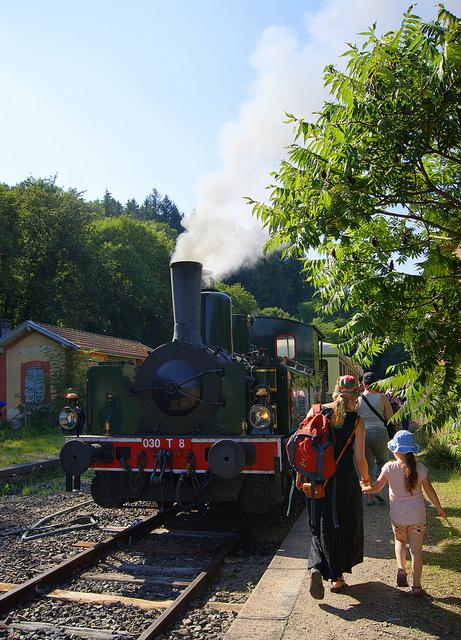What are the people in the forefront doing?
Short answer required. Walking. What are the numbers on the front of the train?
Quick response, please. 8. What gender are the two people?
Be succinct. Female. How many people in this photo?
Answer briefly. 2. What is on the walkers' heads?
Keep it brief. Hats. 